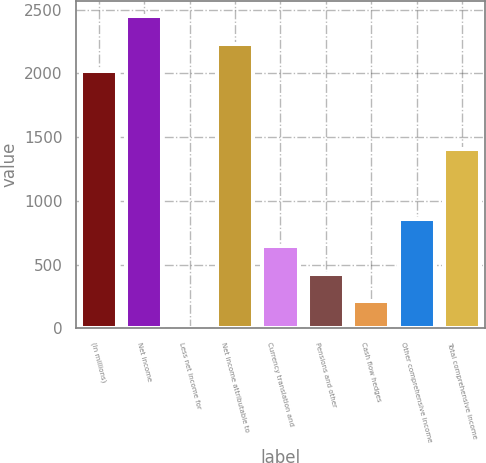<chart> <loc_0><loc_0><loc_500><loc_500><bar_chart><fcel>(In millions)<fcel>Net income<fcel>Less net income for<fcel>Net income attributable to<fcel>Currency translation and<fcel>Pensions and other<fcel>Cash flow hedges<fcel>Other comprehensive income<fcel>Total comprehensive income<nl><fcel>2018<fcel>2447<fcel>1<fcel>2232.5<fcel>644.5<fcel>430<fcel>215.5<fcel>859<fcel>1404<nl></chart> 